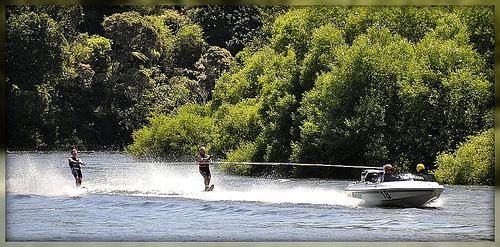What are the two doing behind the boat? water skiing 